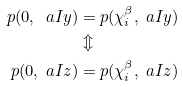<formula> <loc_0><loc_0><loc_500><loc_500>p ( 0 , \ a I { y } ) & = p ( \chi ^ { \beta } _ { i } , \ a I { y } ) \\ & \Updownarrow \\ p ( 0 , \ a I { z } ) & = p ( \chi ^ { \beta } _ { i } , \ a I { z } )</formula> 